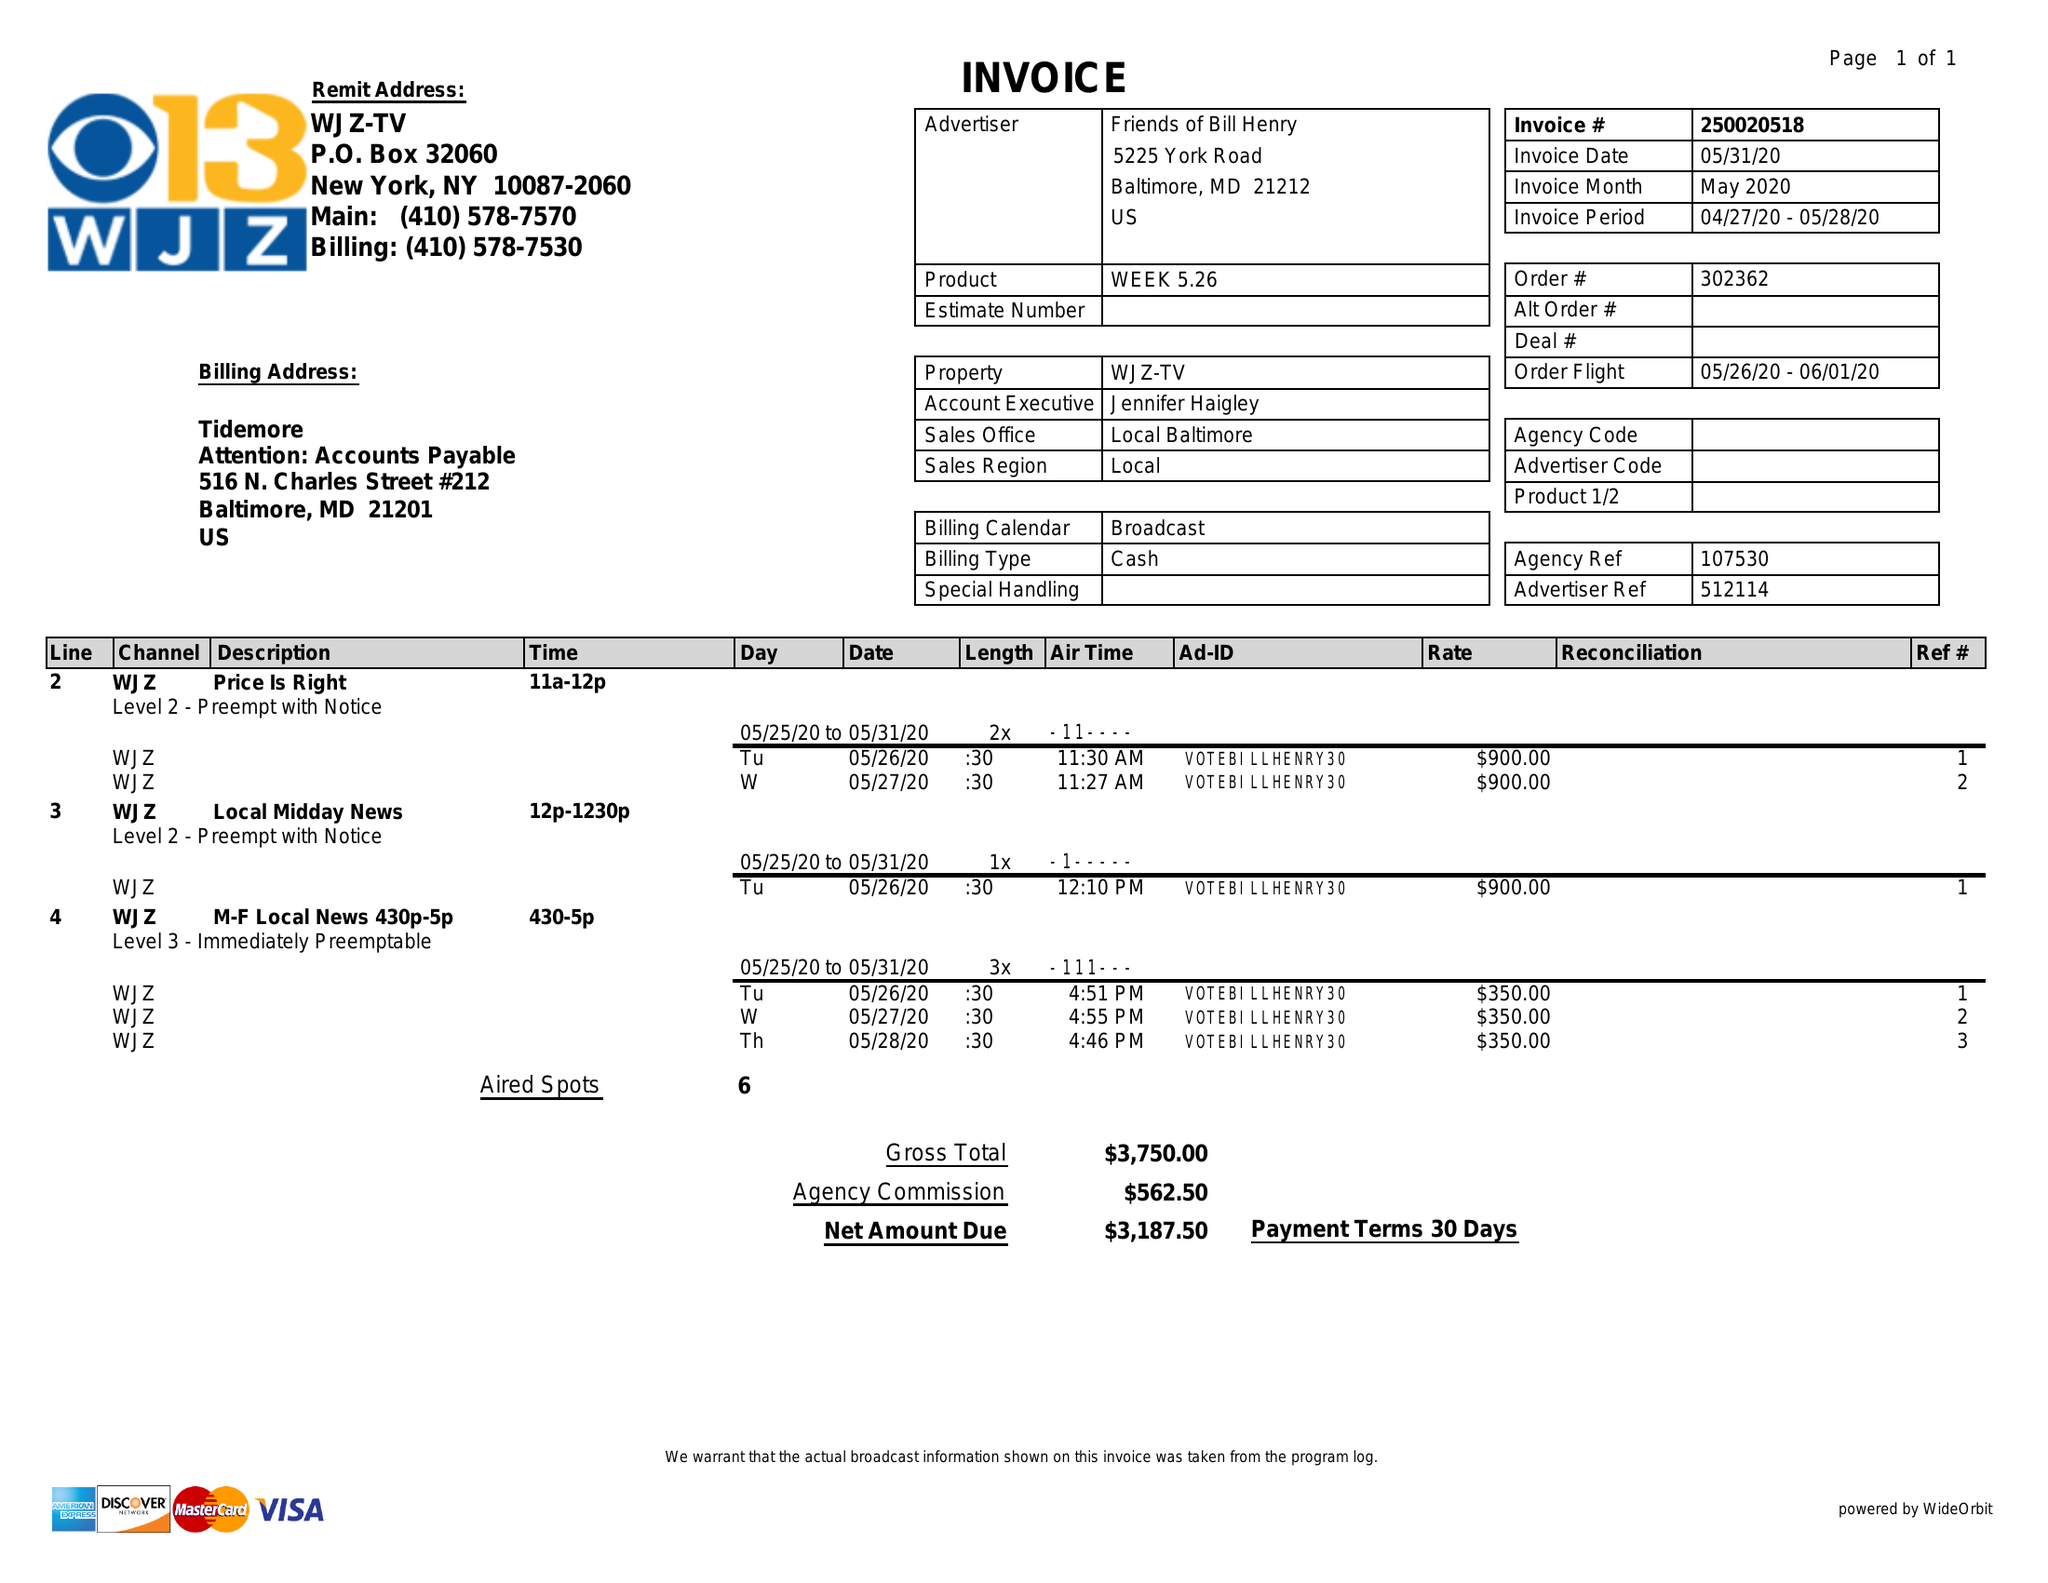What is the value for the flight_from?
Answer the question using a single word or phrase. 05/26/20 